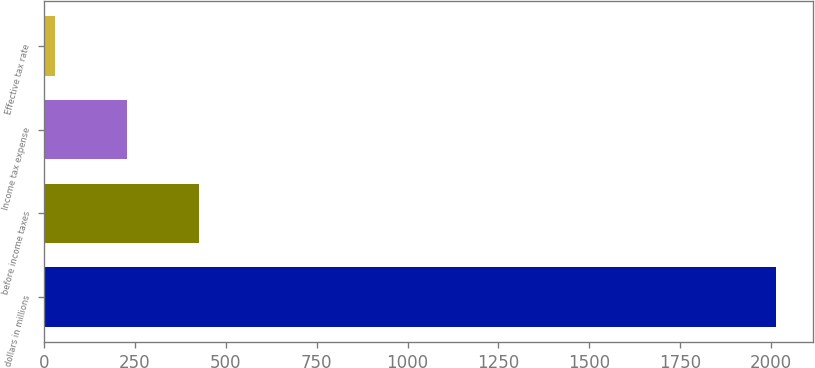Convert chart to OTSL. <chart><loc_0><loc_0><loc_500><loc_500><bar_chart><fcel>dollars in millions<fcel>before income taxes<fcel>Income tax expense<fcel>Effective tax rate<nl><fcel>2014<fcel>427.36<fcel>229.03<fcel>30.7<nl></chart> 